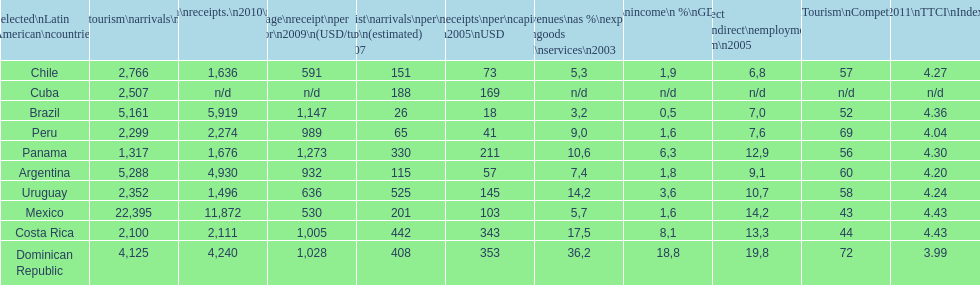Which country had the least amount of tourism income in 2003? Brazil. 